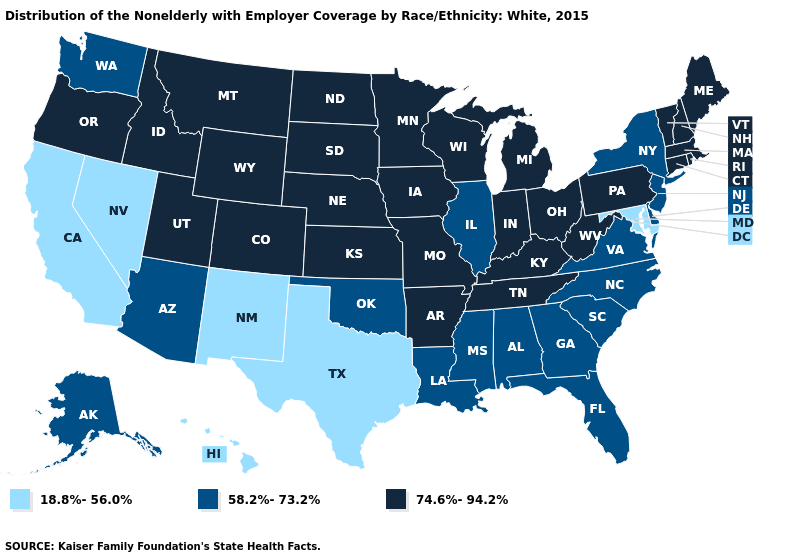Is the legend a continuous bar?
Be succinct. No. Name the states that have a value in the range 74.6%-94.2%?
Answer briefly. Arkansas, Colorado, Connecticut, Idaho, Indiana, Iowa, Kansas, Kentucky, Maine, Massachusetts, Michigan, Minnesota, Missouri, Montana, Nebraska, New Hampshire, North Dakota, Ohio, Oregon, Pennsylvania, Rhode Island, South Dakota, Tennessee, Utah, Vermont, West Virginia, Wisconsin, Wyoming. What is the highest value in the USA?
Be succinct. 74.6%-94.2%. Does Virginia have the highest value in the USA?
Be succinct. No. Does Maine have the highest value in the USA?
Keep it brief. Yes. What is the value of Rhode Island?
Answer briefly. 74.6%-94.2%. How many symbols are there in the legend?
Quick response, please. 3. What is the lowest value in the USA?
Answer briefly. 18.8%-56.0%. Does Montana have a higher value than Texas?
Keep it brief. Yes. What is the value of California?
Quick response, please. 18.8%-56.0%. Does the first symbol in the legend represent the smallest category?
Concise answer only. Yes. What is the value of Alaska?
Write a very short answer. 58.2%-73.2%. Name the states that have a value in the range 18.8%-56.0%?
Quick response, please. California, Hawaii, Maryland, Nevada, New Mexico, Texas. What is the highest value in states that border Nevada?
Be succinct. 74.6%-94.2%. What is the highest value in the USA?
Answer briefly. 74.6%-94.2%. 